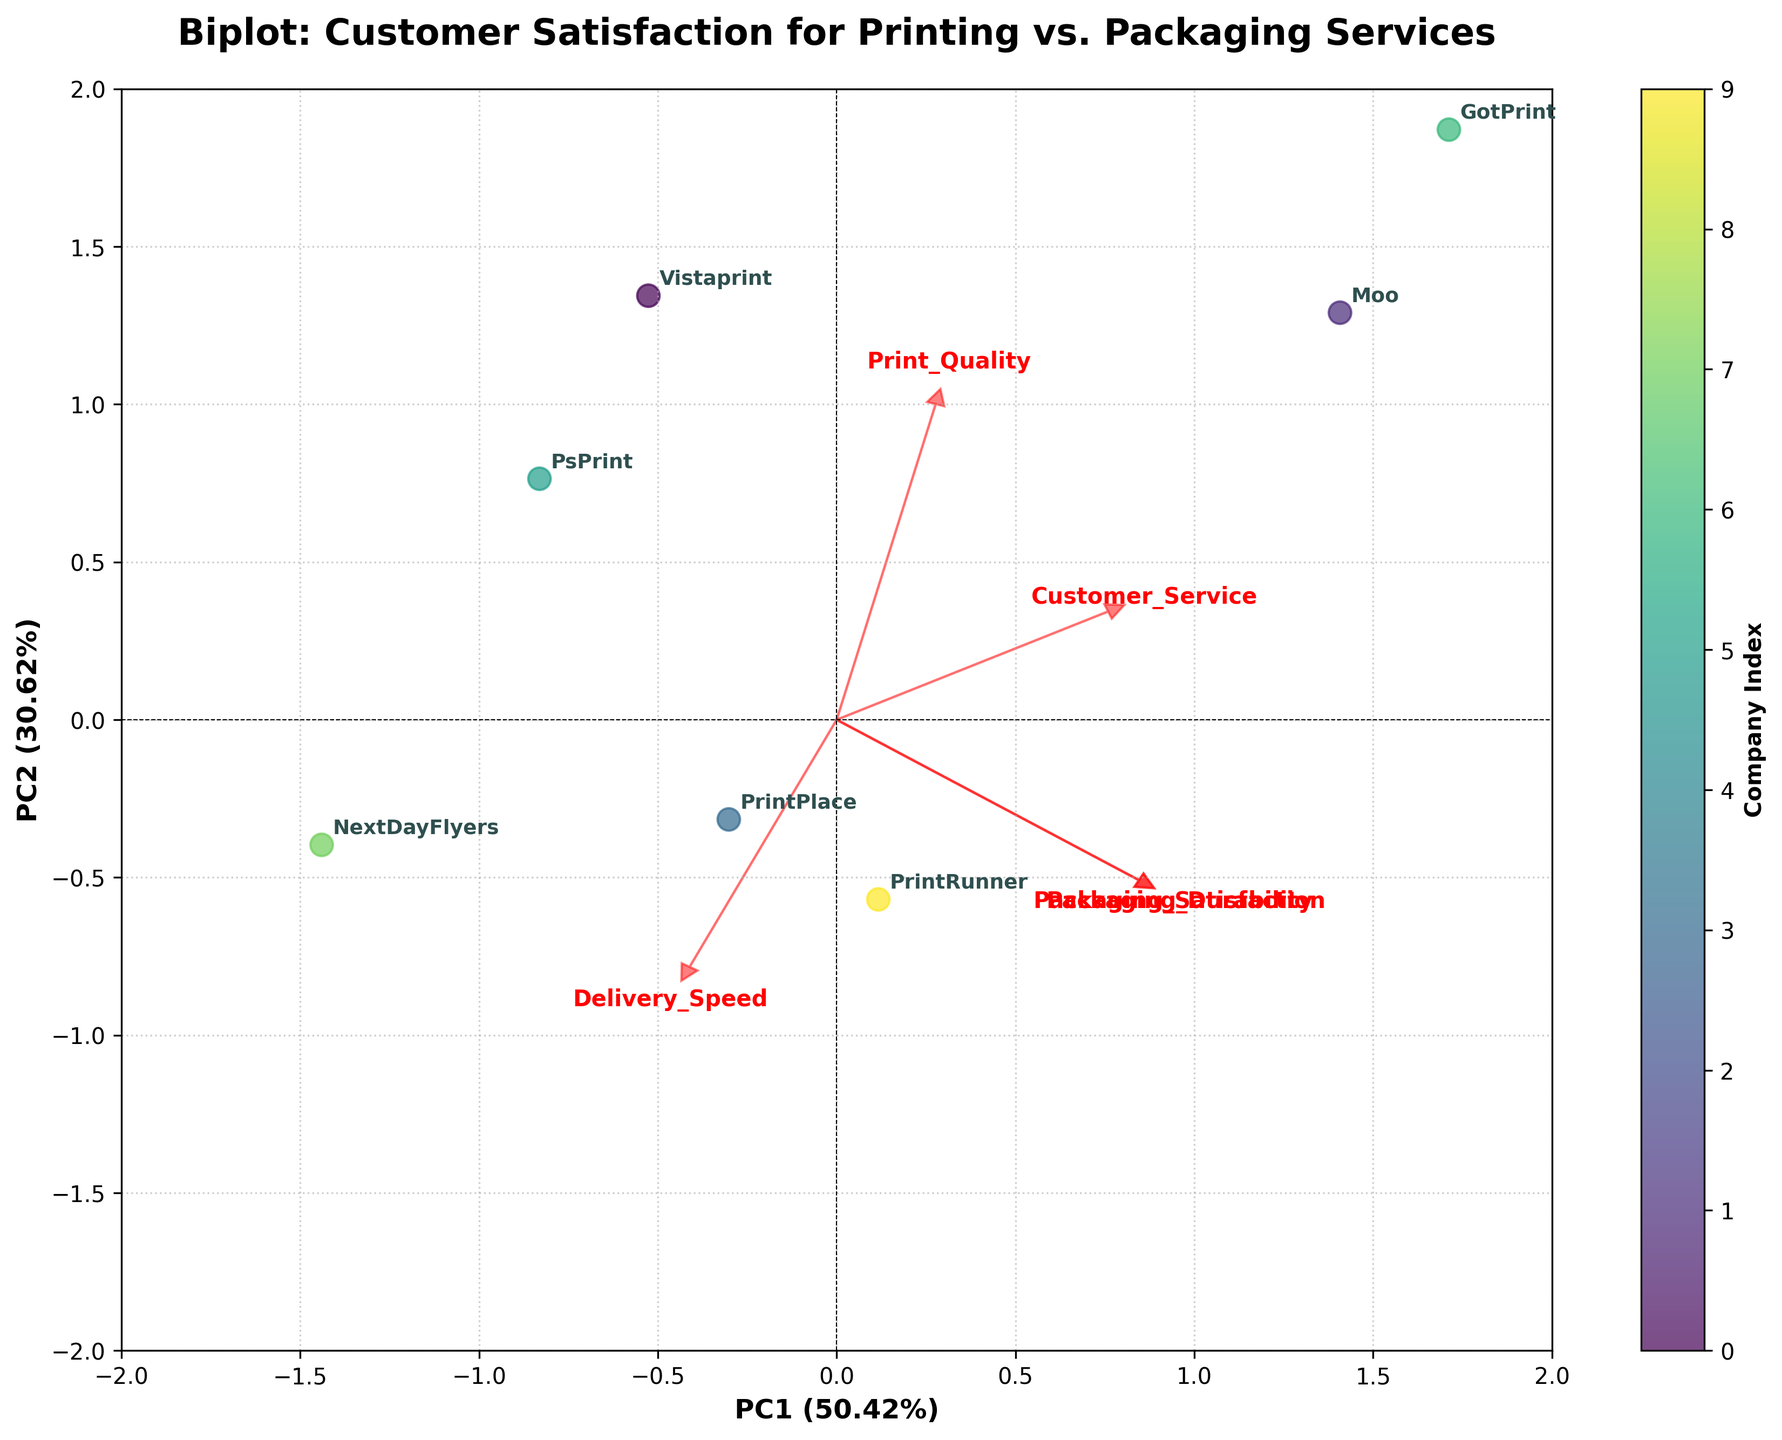What is the title of the biplot? The title of the plot is centered at the top and provides a summary of the visual content. It helps the reader quickly understand what the plot is about.
Answer: Biplot: Customer Satisfaction for Printing vs. Packaging Services Which company has the highest score on the first principal component (PC1)? To find the company with the highest score on the first principal component (PC1), locate the point farthest to the right along the x-axis.
Answer: Moo Which two variables are most strongly associated with PC1? To determine the strongest associations, observe the directions and lengths of the red arrows representing the loadings; the longer the arrow in the direction of PC1, the stronger the association.
Answer: Print_Quality and Delivery_Speed How many companies have a PC2 score greater than 0? Count the points (representing companies) that lie above the x-axis, indicating positive PC2 scores.
Answer: Four Which variable is most strongly associated with PC2? Look for the longest red arrow in the direction of PC2. Its length and direction indicate the variable's strong association with PC2.
Answer: Packaging_Durability Identify the company that has both a medium score on PC1 and a high score on PC2. A medium score on PC1 would be close to the center of the x-axis, and a high PC2 score would be high on the y-axis. Identify the corresponding company.
Answer: 4Over Which companies have similar PC scores, and what might this imply? Look for clusters of points that are close to each other in the biplot. Similar PC scores imply that these companies might have similar strengths and weaknesses in the various factors represented.
Answer: PrintPlace and PrintRunner How do the vectors help in understanding the relationship between variables in the biplot? The vectors (red arrows) indicate both the direction and the strength of each variable's contribution to the principal components. Longer vectors indicate stronger contributions, and their direction shows whether the variables are positively or negatively correlated with each principal component.
Answer: They indicate strength and direction of variable contributions What does it mean if a variable has a short vector in the biplot? A short vector suggests that the variable does not contribute much to either of the principal components, implying lower variance in that direction.
Answer: Lower contribution to principal components What can you infer about customer satisfaction for companies with negative PC1 scores? Companies with negative PC1 scores typically align more with the variables that have negative loadings on PC1. Evaluate those variables to make inferences about what aspects they might be lagging in.
Answer: They may have lower Print_Quality and Delivery_Speed 